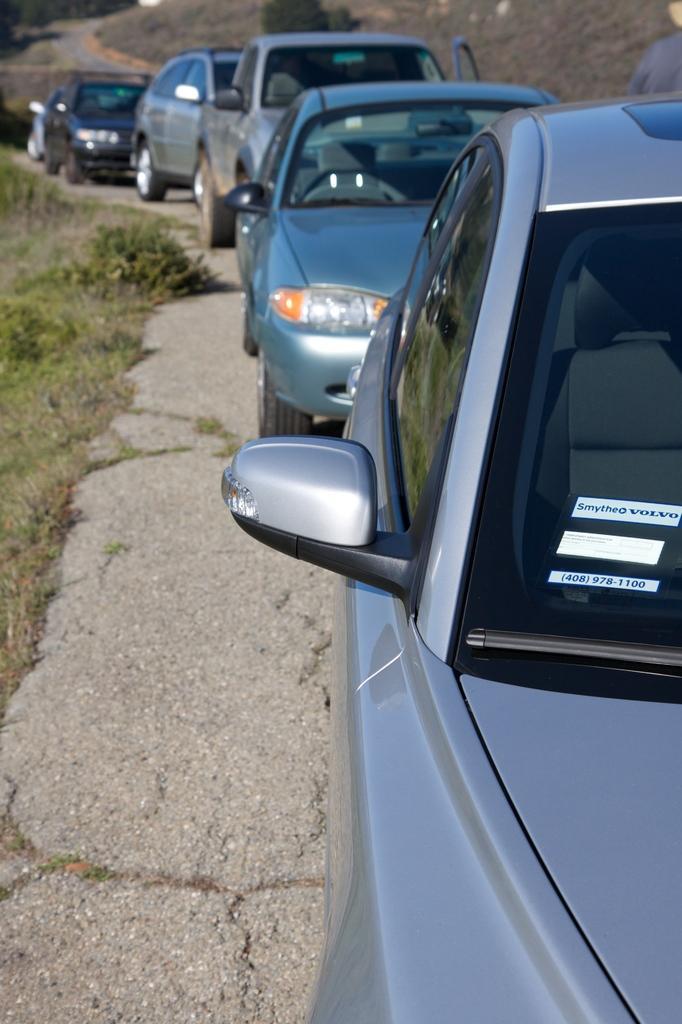Could you give a brief overview of what you see in this image? In this image there is a road, on that road there are cars,on the left side there is grass in the background there is a hill. 